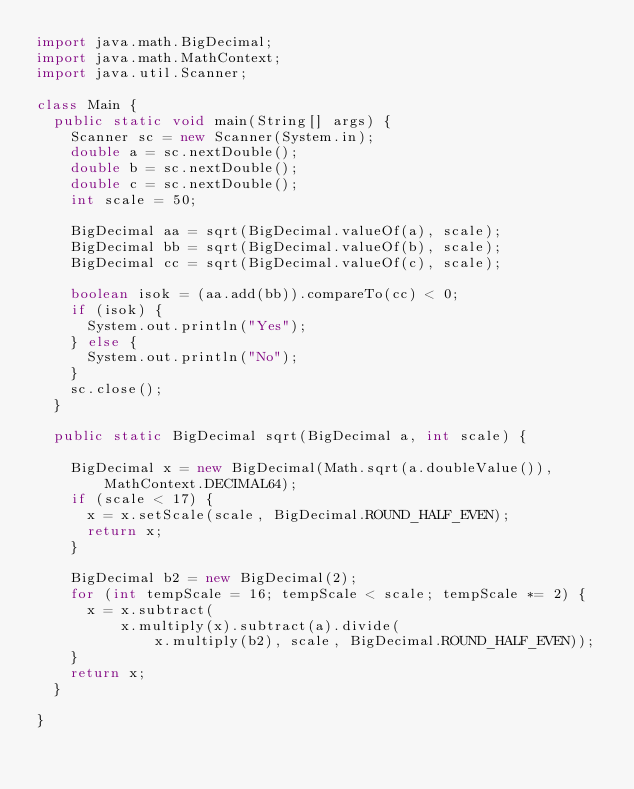<code> <loc_0><loc_0><loc_500><loc_500><_Java_>import java.math.BigDecimal;
import java.math.MathContext;
import java.util.Scanner;

class Main {
	public static void main(String[] args) {
		Scanner sc = new Scanner(System.in);
		double a = sc.nextDouble();
		double b = sc.nextDouble();
		double c = sc.nextDouble();
		int scale = 50;

		BigDecimal aa = sqrt(BigDecimal.valueOf(a), scale);
		BigDecimal bb = sqrt(BigDecimal.valueOf(b), scale);
		BigDecimal cc = sqrt(BigDecimal.valueOf(c), scale);

		boolean isok = (aa.add(bb)).compareTo(cc) < 0;
		if (isok) {
			System.out.println("Yes");
		} else {
			System.out.println("No");
		}
		sc.close();
	}

	public static BigDecimal sqrt(BigDecimal a, int scale) {

		BigDecimal x = new BigDecimal(Math.sqrt(a.doubleValue()), MathContext.DECIMAL64);
		if (scale < 17) {
			x = x.setScale(scale, BigDecimal.ROUND_HALF_EVEN);
			return x;
		}

		BigDecimal b2 = new BigDecimal(2);
		for (int tempScale = 16; tempScale < scale; tempScale *= 2) {
			x = x.subtract(
					x.multiply(x).subtract(a).divide(
							x.multiply(b2), scale, BigDecimal.ROUND_HALF_EVEN));
		}
		return x;
	}

}
</code> 